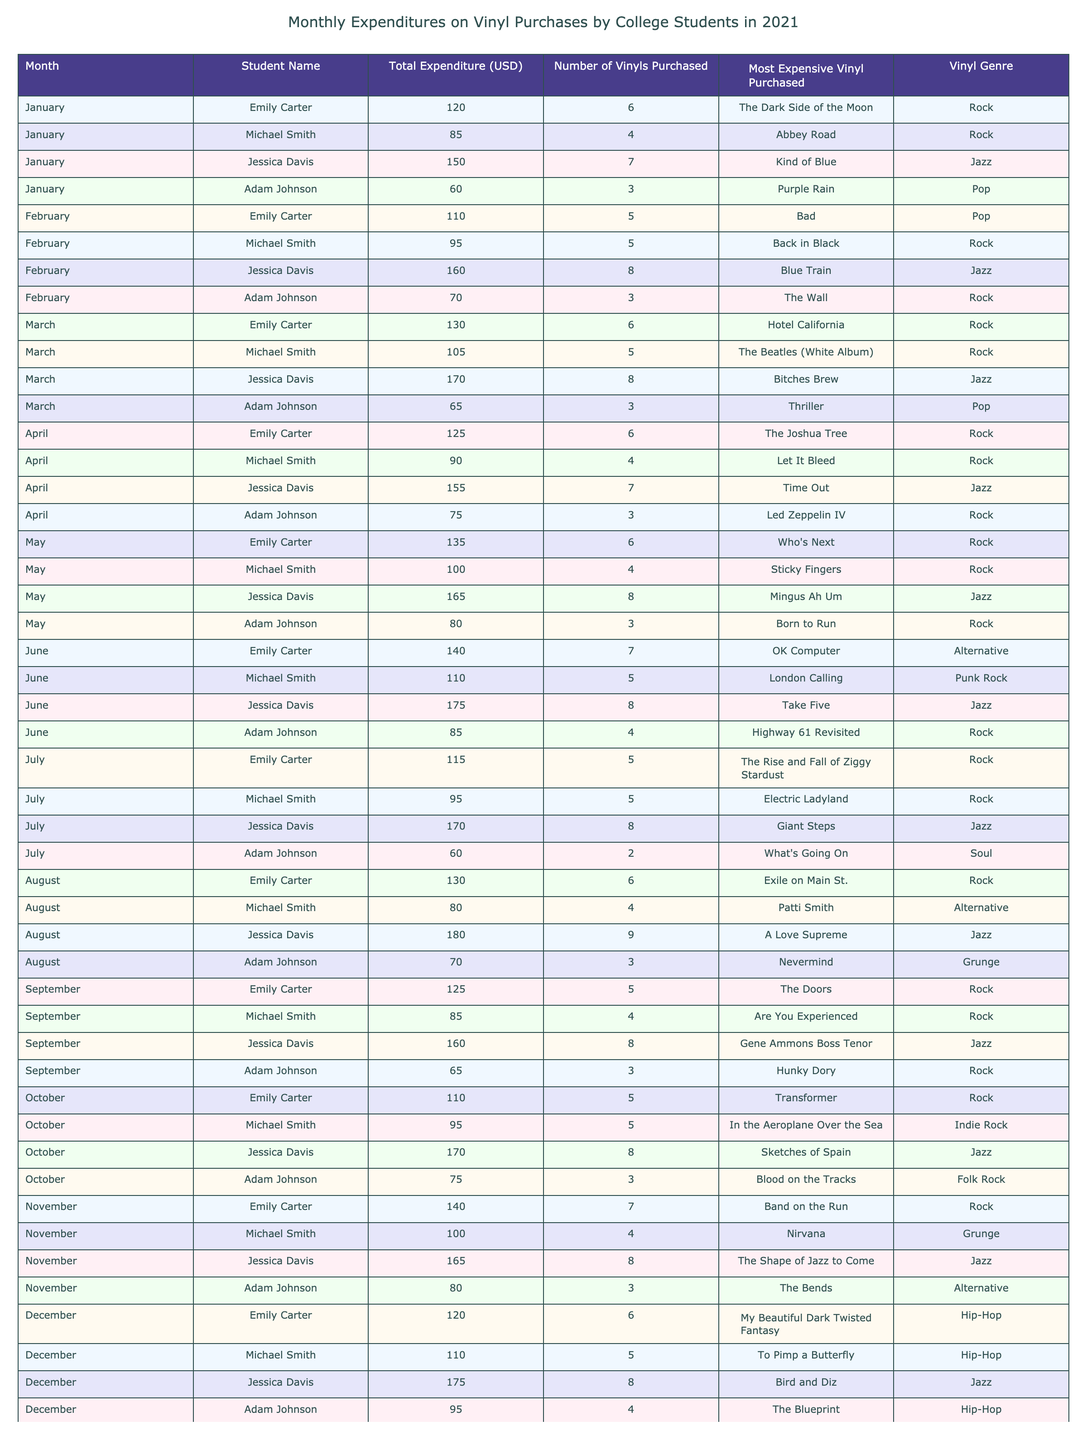What is the total expenditure for Jessica Davis in May? From the table, Jessica Davis's Total Expenditure for May is directly listed as 165 USD.
Answer: 165 USD How many vinyls did Adam Johnson purchase in March? In the March row for Adam Johnson, the Number of Vinyls Purchased is indicated as 3.
Answer: 3 What is the average total expenditure across all students for the month of April? The total expenditures for April are Emily (125), Michael (90), Jessica (155), and Adam (75). Adding them gives us a total of 125 + 90 + 155 + 75 = 445. Since there are 4 students, the average is 445/4 = 111.25.
Answer: 111.25 USD Did Emily Carter spend more than 100 USD in January? In January, Emily Carter's Total Expenditure is listed as 120 USD, which is indeed greater than 100 USD.
Answer: Yes Which genre was the most expensive vinyl purchased by Jessica Davis in June? According to the June entry for Jessica Davis, the Most Expensive Vinyl Purchased is "Take Five", which belongs to the Jazz genre.
Answer: Jazz What is the difference in total expenditure between Emily Carter in February and March? For Emily Carter, the Total Expenditure in February is 110 USD and in March is 130 USD. To find the difference, we calculate 130 - 110 = 20.
Answer: 20 USD How many vinyls in total did Michael Smith purchase throughout the year? By adding the Number of Vinyls Purchased for each month: January (4) + February (5) + March (5) + April (4) + May (4) + June (5) + July (5) + August (4) + September (4) + October (5) + November (4) + December (5) = 54 total vinyls purchased by Michael Smith over the year.
Answer: 54 Was the most expensive vinyl purchased by Adam Johnson in October a Folk Rock album? In the October row for Adam Johnson, the Most Expensive Vinyl Purchased is "Blood on the Tracks", which is categorized under Folk Rock. Therefore, the statement is true.
Answer: Yes What was the month when Jessica Davis purchased the highest number of vinyls? By reviewing each month's Number of Vinyls Purchased for Jessica Davis, the highest number is 9, which occurs in August.
Answer: August 